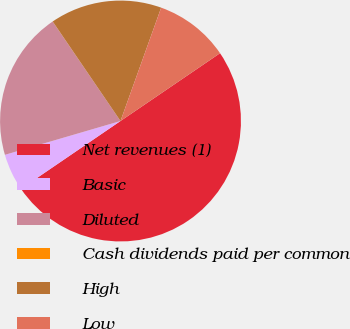Convert chart to OTSL. <chart><loc_0><loc_0><loc_500><loc_500><pie_chart><fcel>Net revenues (1)<fcel>Basic<fcel>Diluted<fcel>Cash dividends paid per common<fcel>High<fcel>Low<nl><fcel>49.99%<fcel>5.0%<fcel>20.0%<fcel>0.01%<fcel>15.0%<fcel>10.0%<nl></chart> 